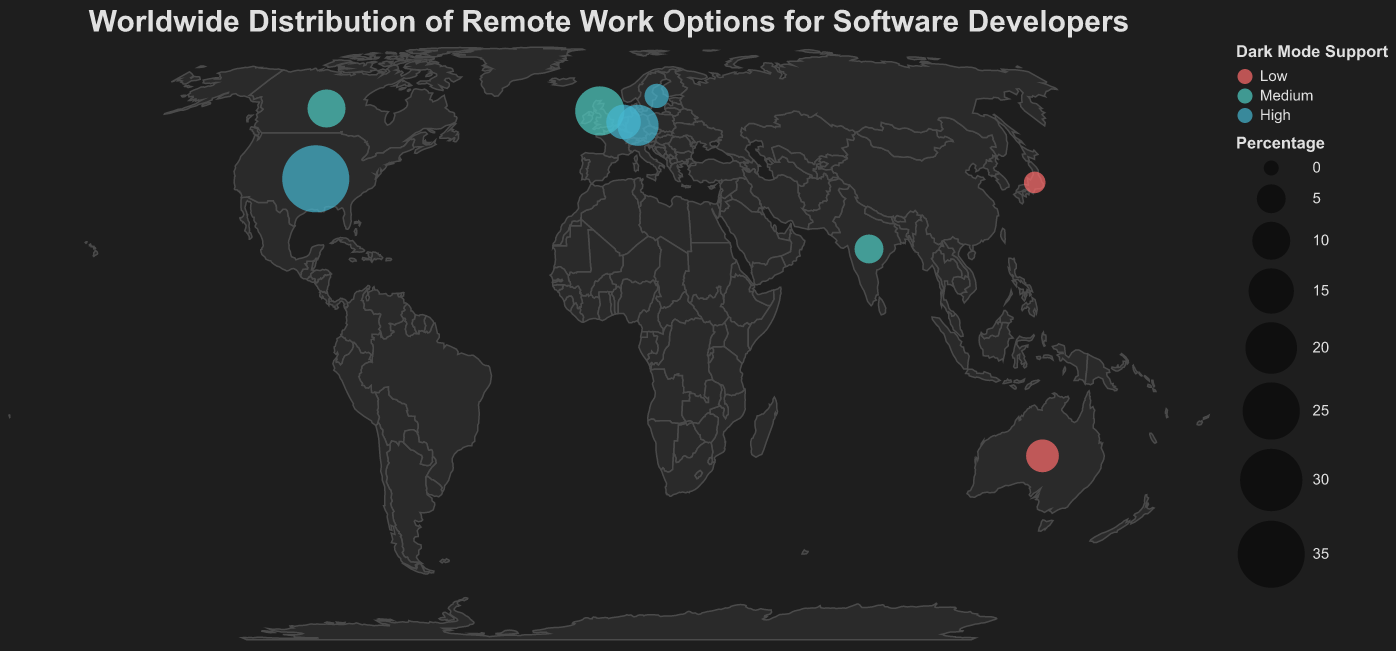What is the title of the figure? The title is the text displayed at the top of the figure, usually in a larger font and a color different from the rest of the plot.
Answer: Worldwide Distribution of Remote Work Options for Software Developers Which country has the highest percentage of companies offering remote work options? The largest circle on the map represents the country with the highest percentage. The United States has the largest circle.
Answer: United States How many countries are displayed in the plot? Count the number of distinct circles on the map that represent different countries.
Answer: 9 Which countries have high dark mode support? Check the color of the circles. Countries with high dark mode support are shown in a specific color (an aqua shade).
Answer: United States, Germany, Netherlands, Sweden What is the combined percentage of companies offering remote work in the United Kingdom and Canada? Add the percentages of these two countries. United Kingdom has 18% and Canada has 10%. 18 + 10 = 28
Answer: 28% Which country has the lowest percentage of companies offering remote work? The smallest circle on the map represents the country with the lowest percentage. Japan has the smallest circle.
Answer: Japan Compare the dark mode support between Australia and India. Check the color of the circles for each country. Australia has low dark mode support (red), and India has medium dark mode support (turquoise).
Answer: Australia: Low, India: Medium Which countries have medium dark mode support? Identify the circles colored in the shade that represents medium dark mode support (turquoise).
Answer: United Kingdom, Canada, India What is the total percentage of companies offering remote work options across all countries? Sum the percentages of all countries. 35 (US) + 18 (UK) + 12 (Germany) + 10 (Canada) + 8 (Netherlands) + 7 (Australia) + 5 (India) + 3 (Sweden) + 2 (Japan) = 100
Answer: 100 Which country has the closest percentage to Germany in offering remote work options? Compare the percentages and identify the closest value. Germany has 12%, and the closest is Canada with 10%.
Answer: Canada 